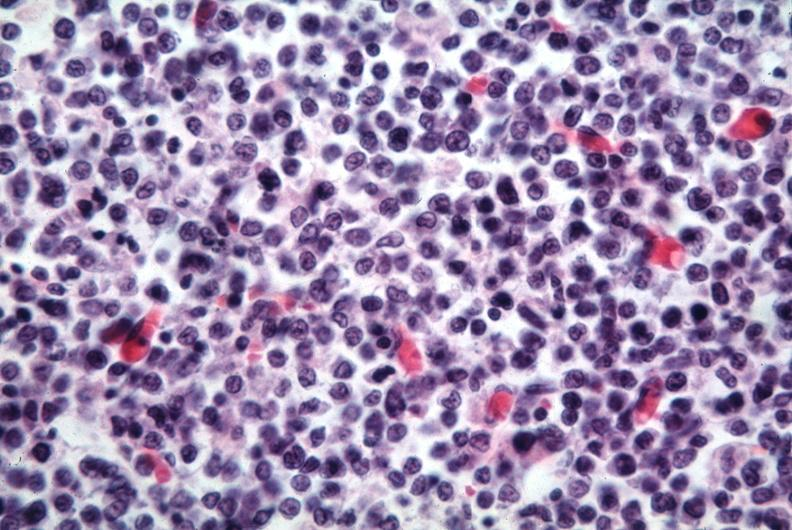does this image show lymphoma cells?
Answer the question using a single word or phrase. Yes 